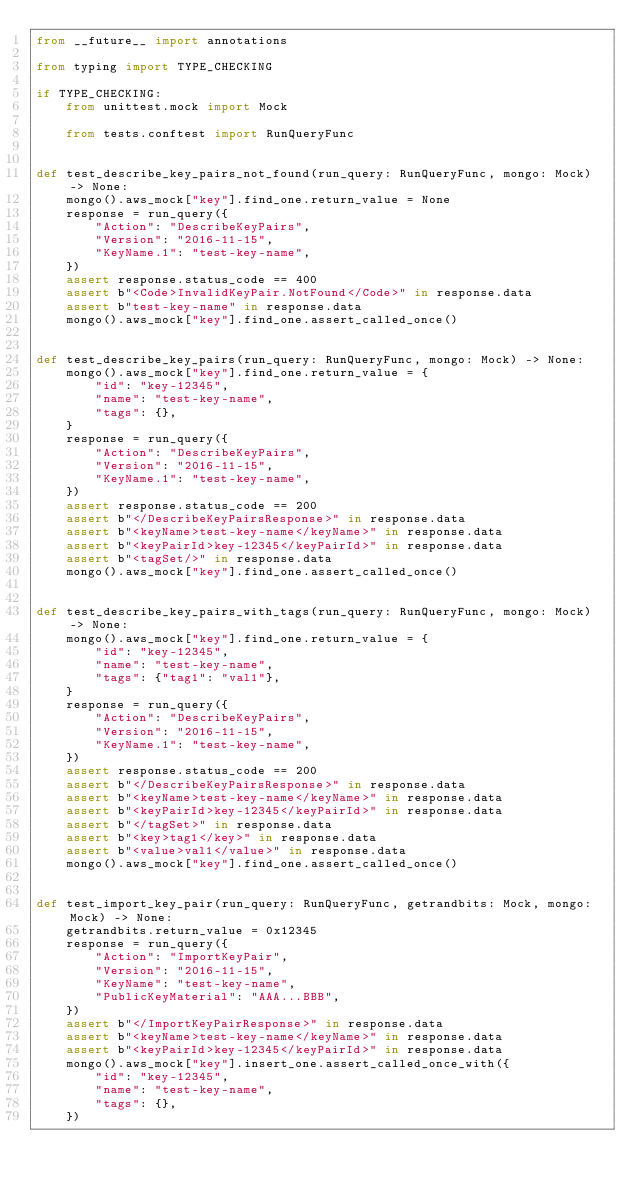Convert code to text. <code><loc_0><loc_0><loc_500><loc_500><_Python_>from __future__ import annotations

from typing import TYPE_CHECKING

if TYPE_CHECKING:
    from unittest.mock import Mock

    from tests.conftest import RunQueryFunc


def test_describe_key_pairs_not_found(run_query: RunQueryFunc, mongo: Mock) -> None:
    mongo().aws_mock["key"].find_one.return_value = None
    response = run_query({
        "Action": "DescribeKeyPairs",
        "Version": "2016-11-15",
        "KeyName.1": "test-key-name",
    })
    assert response.status_code == 400
    assert b"<Code>InvalidKeyPair.NotFound</Code>" in response.data
    assert b"test-key-name" in response.data
    mongo().aws_mock["key"].find_one.assert_called_once()


def test_describe_key_pairs(run_query: RunQueryFunc, mongo: Mock) -> None:
    mongo().aws_mock["key"].find_one.return_value = {
        "id": "key-12345",
        "name": "test-key-name",
        "tags": {},
    }
    response = run_query({
        "Action": "DescribeKeyPairs",
        "Version": "2016-11-15",
        "KeyName.1": "test-key-name",
    })
    assert response.status_code == 200
    assert b"</DescribeKeyPairsResponse>" in response.data
    assert b"<keyName>test-key-name</keyName>" in response.data
    assert b"<keyPairId>key-12345</keyPairId>" in response.data
    assert b"<tagSet/>" in response.data
    mongo().aws_mock["key"].find_one.assert_called_once()


def test_describe_key_pairs_with_tags(run_query: RunQueryFunc, mongo: Mock) -> None:
    mongo().aws_mock["key"].find_one.return_value = {
        "id": "key-12345",
        "name": "test-key-name",
        "tags": {"tag1": "val1"},
    }
    response = run_query({
        "Action": "DescribeKeyPairs",
        "Version": "2016-11-15",
        "KeyName.1": "test-key-name",
    })
    assert response.status_code == 200
    assert b"</DescribeKeyPairsResponse>" in response.data
    assert b"<keyName>test-key-name</keyName>" in response.data
    assert b"<keyPairId>key-12345</keyPairId>" in response.data
    assert b"</tagSet>" in response.data
    assert b"<key>tag1</key>" in response.data
    assert b"<value>val1</value>" in response.data
    mongo().aws_mock["key"].find_one.assert_called_once()


def test_import_key_pair(run_query: RunQueryFunc, getrandbits: Mock, mongo: Mock) -> None:
    getrandbits.return_value = 0x12345
    response = run_query({
        "Action": "ImportKeyPair",
        "Version": "2016-11-15",
        "KeyName": "test-key-name",
        "PublicKeyMaterial": "AAA...BBB",
    })
    assert b"</ImportKeyPairResponse>" in response.data
    assert b"<keyName>test-key-name</keyName>" in response.data
    assert b"<keyPairId>key-12345</keyPairId>" in response.data
    mongo().aws_mock["key"].insert_one.assert_called_once_with({
        "id": "key-12345",
        "name": "test-key-name",
        "tags": {},
    })
</code> 